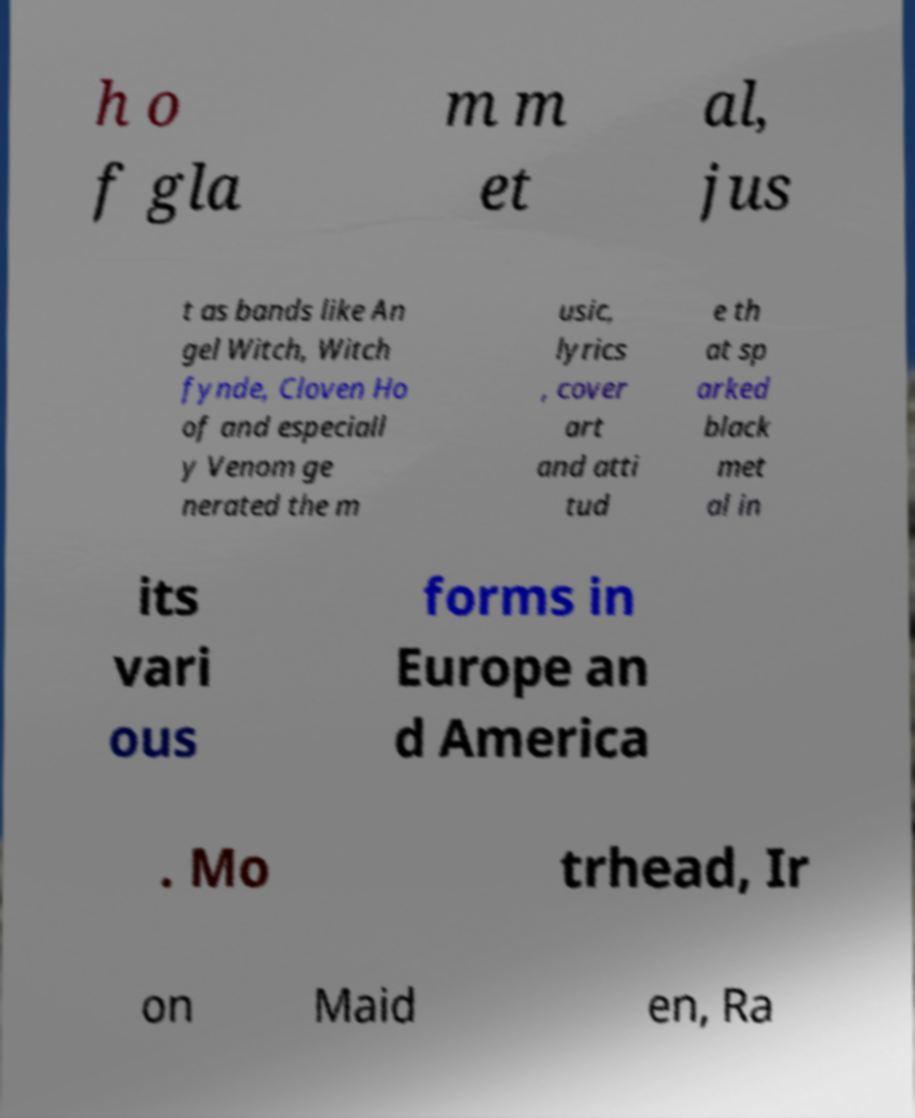Can you accurately transcribe the text from the provided image for me? h o f gla m m et al, jus t as bands like An gel Witch, Witch fynde, Cloven Ho of and especiall y Venom ge nerated the m usic, lyrics , cover art and atti tud e th at sp arked black met al in its vari ous forms in Europe an d America . Mo trhead, Ir on Maid en, Ra 